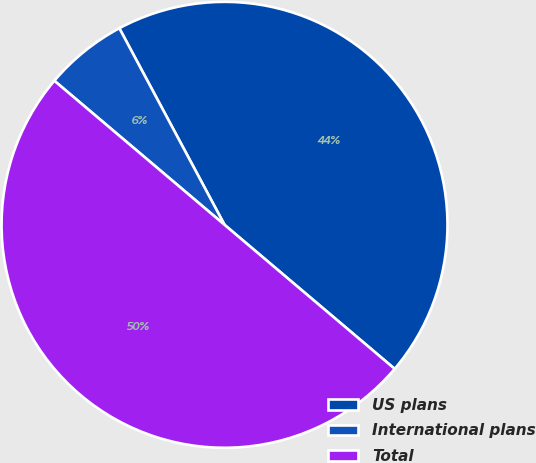Convert chart. <chart><loc_0><loc_0><loc_500><loc_500><pie_chart><fcel>US plans<fcel>International plans<fcel>Total<nl><fcel>44.0%<fcel>6.0%<fcel>50.0%<nl></chart> 